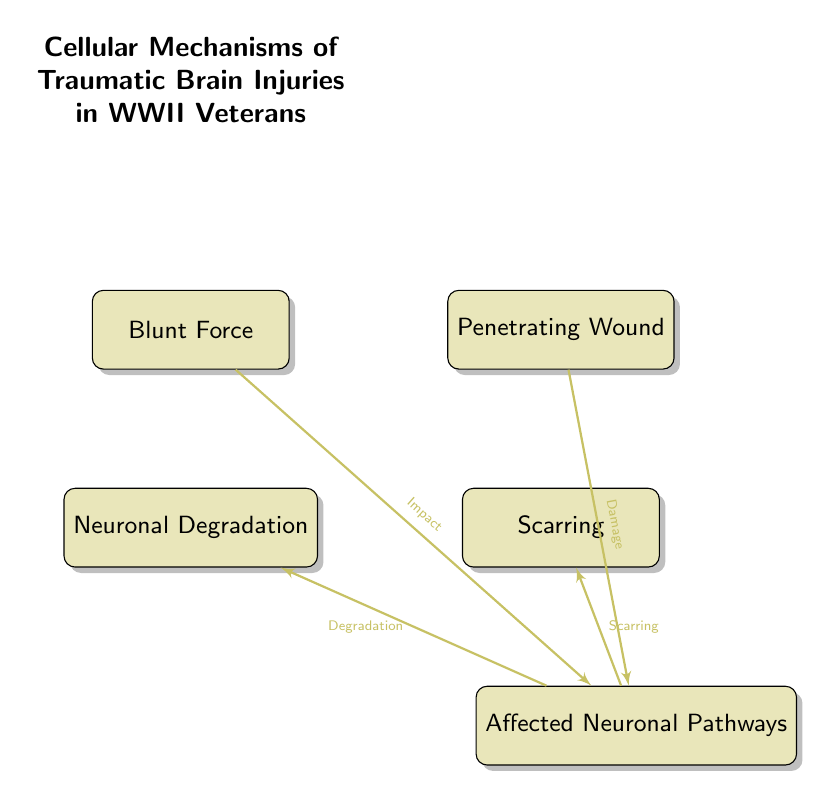What are the types of injuries depicted in the diagram? The diagram shows two types of injuries: "Blunt Force" and "Penetrating Wound." These nodes are labeled and positioned at the top of the diagram.
Answer: Blunt Force, Penetrating Wound How many physiological impacts are indicated in the diagram? The diagram presents two physiological impacts: "Neuronal Degradation" and "Scarring." These are two nodes located at the bottom of the diagram.
Answer: 2 What is the relationship between "Blunt Force" and "Affected Neuronal Pathways"? The diagram shows a directional edge from "Blunt Force" to "Affected Neuronal Pathways," labeled "Impact." This indicates that blunt force injuries lead to an impact on the neuronal pathways.
Answer: Impact Which physiological impact is linked to "Affected Neuronal Pathways"? The node "Affected Neuronal Pathways" has two outgoing connections: one leads to "Neuronal Degradation" and the other to "Scarring," meaning both are linked to the affected pathways.
Answer: Neuronal Degradation, Scarring What theory is suggested by the node "Affected Neuronal Pathways"? The diagram suggests that both types of injuries (blunt force and penetrating wounds) damage the affected neuronal pathways, causing their degradation and subsequent scarring, illustrating a cause-effect relationship.
Answer: Cause-effect relationship What is the impact of penetrating wounds shown in the diagram? The diagram indicates that "Penetrating Wound" leads to "Affected Neuronal Pathways," which subsequently informs the physiological impacts of neuronal degradation and scarring. This highlights the damaging effects of penetrating wounds.
Answer: Damage to neuronal pathways 